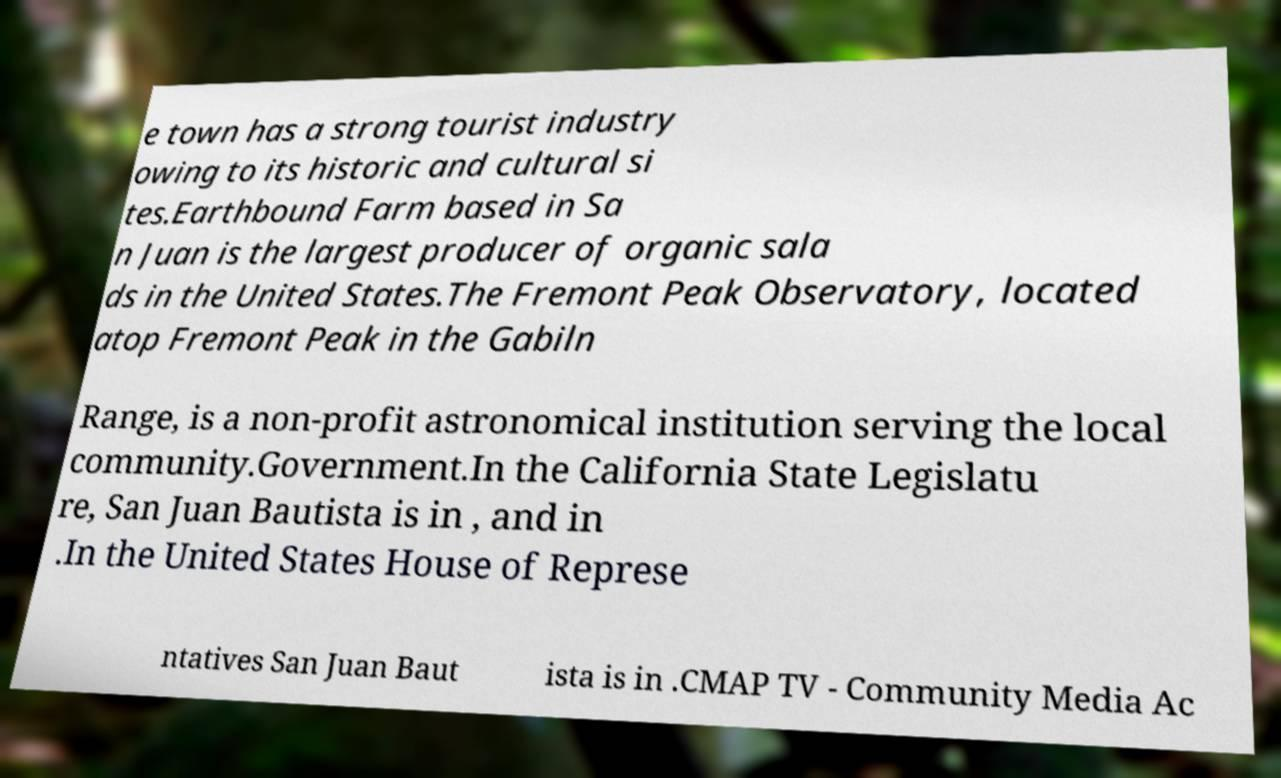Could you extract and type out the text from this image? e town has a strong tourist industry owing to its historic and cultural si tes.Earthbound Farm based in Sa n Juan is the largest producer of organic sala ds in the United States.The Fremont Peak Observatory, located atop Fremont Peak in the Gabiln Range, is a non-profit astronomical institution serving the local community.Government.In the California State Legislatu re, San Juan Bautista is in , and in .In the United States House of Represe ntatives San Juan Baut ista is in .CMAP TV - Community Media Ac 